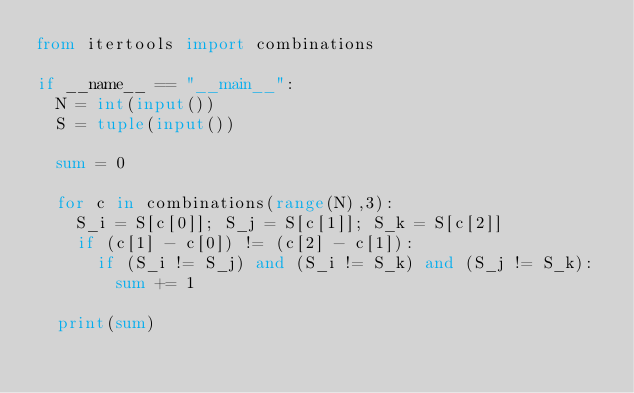Convert code to text. <code><loc_0><loc_0><loc_500><loc_500><_Python_>from itertools import combinations

if __name__ == "__main__":
	N = int(input())
	S = tuple(input())

	sum = 0

	for c in combinations(range(N),3):
		S_i = S[c[0]]; S_j = S[c[1]]; S_k = S[c[2]]
		if (c[1] - c[0]) != (c[2] - c[1]):
			if (S_i != S_j) and (S_i != S_k) and (S_j != S_k):
				sum += 1

	print(sum)</code> 